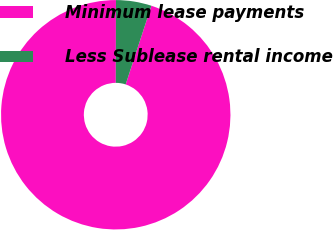<chart> <loc_0><loc_0><loc_500><loc_500><pie_chart><fcel>Minimum lease payments<fcel>Less Sublease rental income<nl><fcel>95.0%<fcel>5.0%<nl></chart> 